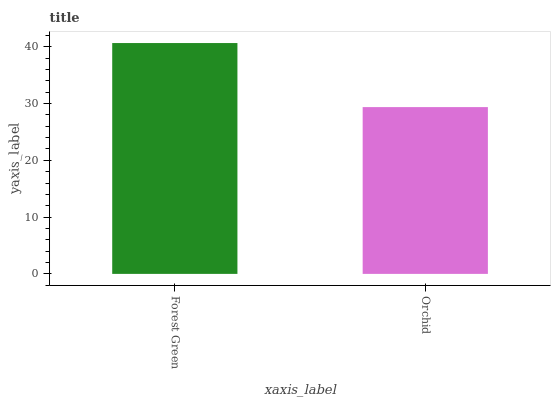Is Orchid the minimum?
Answer yes or no. Yes. Is Forest Green the maximum?
Answer yes or no. Yes. Is Orchid the maximum?
Answer yes or no. No. Is Forest Green greater than Orchid?
Answer yes or no. Yes. Is Orchid less than Forest Green?
Answer yes or no. Yes. Is Orchid greater than Forest Green?
Answer yes or no. No. Is Forest Green less than Orchid?
Answer yes or no. No. Is Forest Green the high median?
Answer yes or no. Yes. Is Orchid the low median?
Answer yes or no. Yes. Is Orchid the high median?
Answer yes or no. No. Is Forest Green the low median?
Answer yes or no. No. 